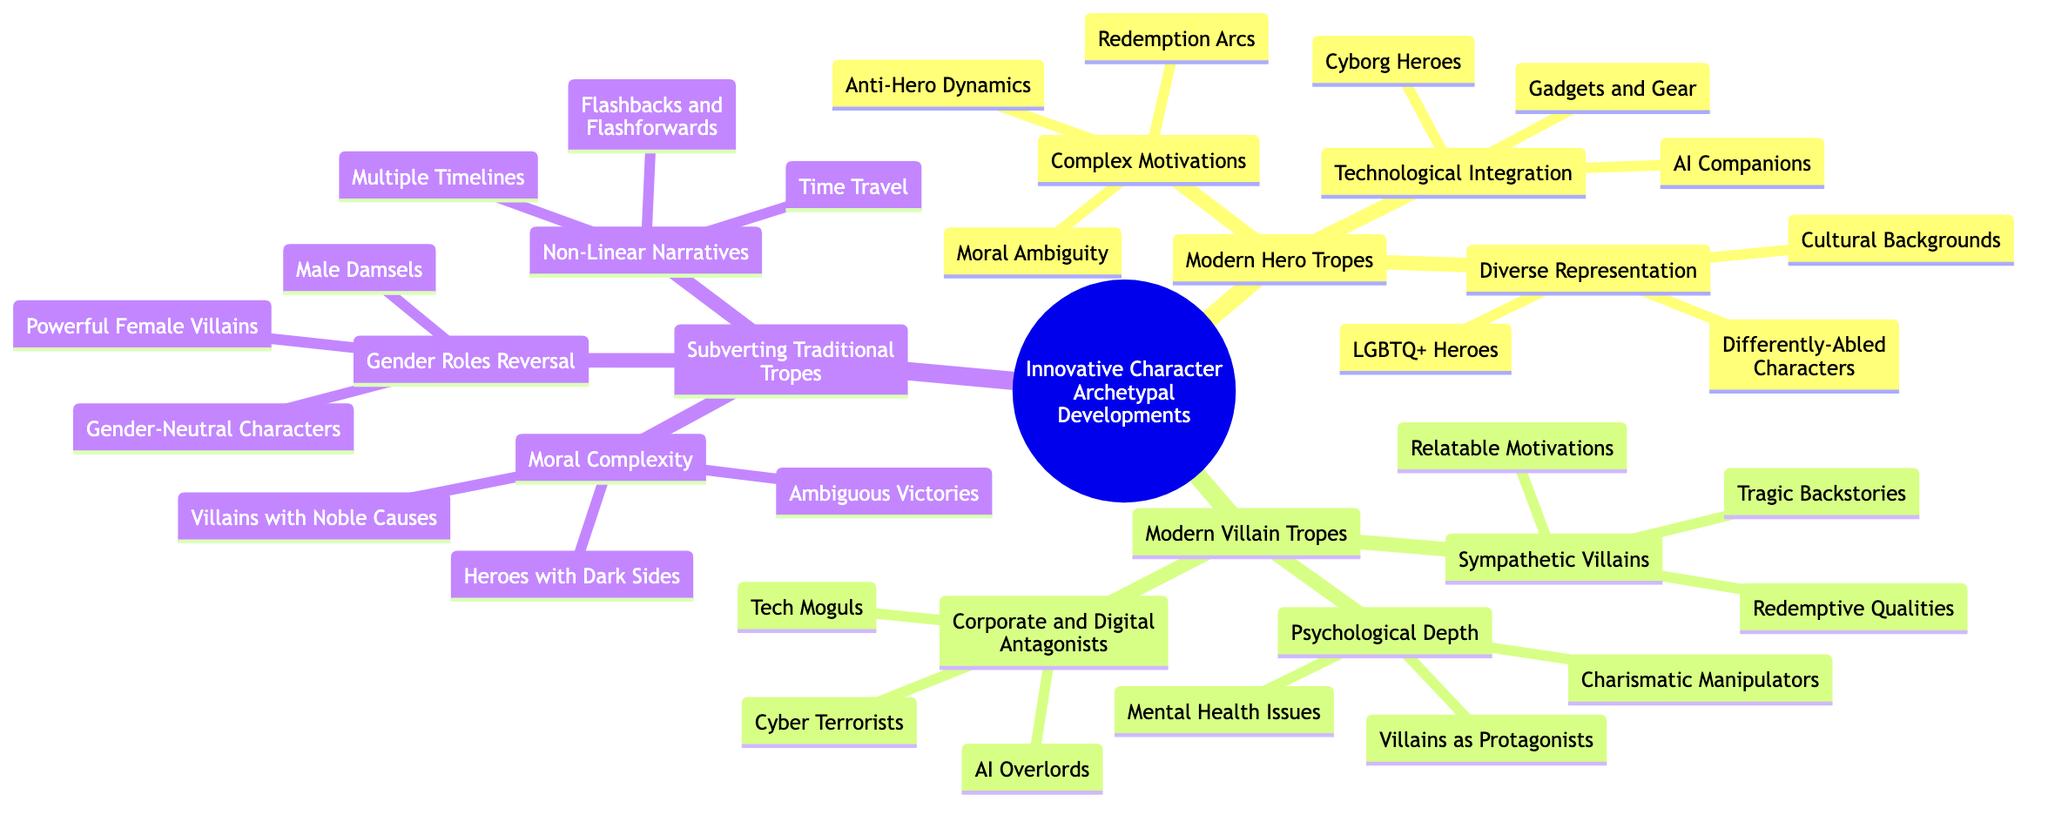What are the three categories under Modern Hero Tropes? The diagram lists the three categories as Complex Motivations, Technological Integration, and Diverse Representation. These categories represent different aspects of how modern heroes are characterized.
Answer: Complex Motivations, Technological Integration, Diverse Representation How many types of antagonists are listed under Modern Villain Tropes? Under Modern Villain Tropes, there are three types mentioned: Sympathetic Villains, Corporate and Digital Antagonists, and Psychological Depth. This indicates a structured approach to defining villain archetypes in modern storytelling.
Answer: 3 Which type of villain has a trait of "Charismatic Manipulators"? "Charismatic Manipulators" is a trait found under the "Psychological Depth" category of Modern Villain Tropes. This category emphasizes the psychological layers that modern villains may possess.
Answer: Psychological Depth What represents the subversion of gender roles in storytelling? The Mind Map indicates that "Gender Roles Reversal" includes Powerful Female Villains, Male Damsels, and Gender-Neutral Characters. This reflects a shift from traditional roles to more modern interpretations in character development.
Answer: Gender Roles Reversal Which modern hero trope includes "Cyborg Heroes"? "Cyborg Heroes" is part of the "Technological Integration" category under Modern Hero Tropes. This signifies an incorporation of technology into the character designs of heroes.
Answer: Technological Integration What is one example of a sympathetic villain trait mentioned in the diagram? One example of a sympathetic villain trait is "Tragic Backstories", which illustrates how villains may have experiences that evoke empathy from the audience.
Answer: Tragic Backstories How many representations of diversity are mentioned under Diverse Representation? Under Diverse Representation, there are three representations mentioned: LGBTQ+ Heroes, Cultural Backgrounds, and Differently-Abled Characters, emphasizing the importance of inclusivity in character development.
Answer: 3 What is a modern storytelling method highlighted in Non-Linear Narratives? One modern storytelling method highlighted is "Multiple Timelines", which indicates a non-traditional approach to narrative structure. This method often complicates the chronological flow of the story.
Answer: Multiple Timelines What villain trope emphasizes "Mental Health Issues"? "Mental Health Issues" is emphasized under the "Psychological Depth" category within Modern Villain Tropes, showcasing a complex and realistic portrayal of antagonists.
Answer: Psychological Depth 